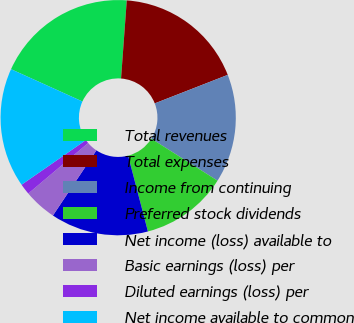<chart> <loc_0><loc_0><loc_500><loc_500><pie_chart><fcel>Total revenues<fcel>Total expenses<fcel>Income from continuing<fcel>Preferred stock dividends<fcel>Net income (loss) available to<fcel>Basic earnings (loss) per<fcel>Diluted earnings (loss) per<fcel>Net income available to common<nl><fcel>19.4%<fcel>17.91%<fcel>14.92%<fcel>11.94%<fcel>13.43%<fcel>4.48%<fcel>1.5%<fcel>16.42%<nl></chart> 